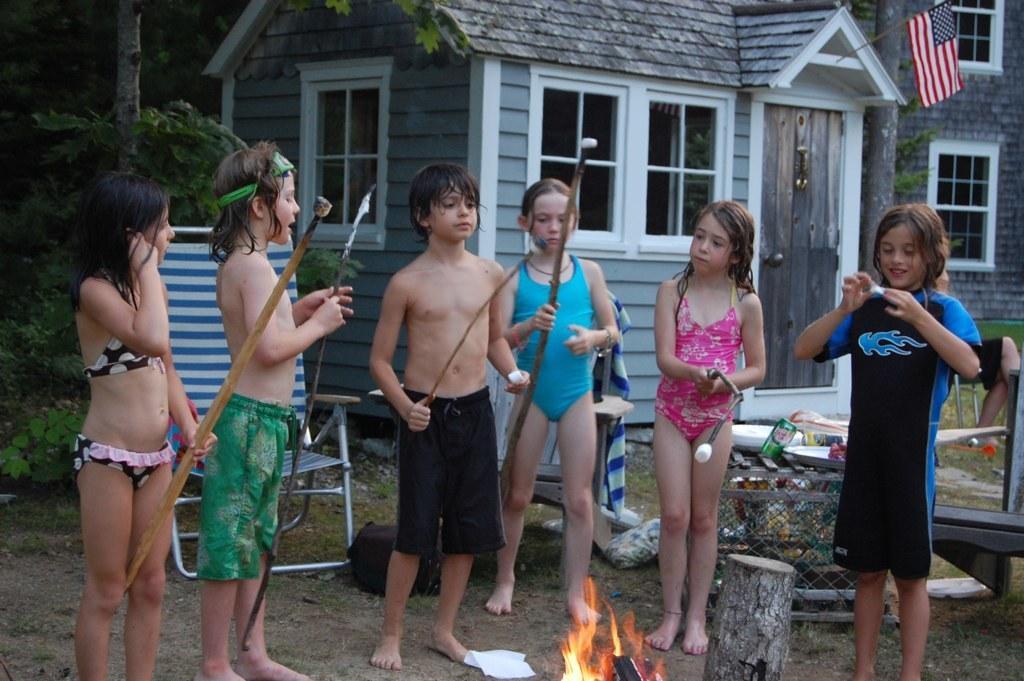In one or two sentences, can you explain what this image depicts? In this picture we can see few kids are standing, four of them are holding sticks, at the bottom there is fire, on the left side we can see a chair, there is a plate and a tin in the middle, in the background there is a house and trees, we can see a flag at the right top of the picture. 